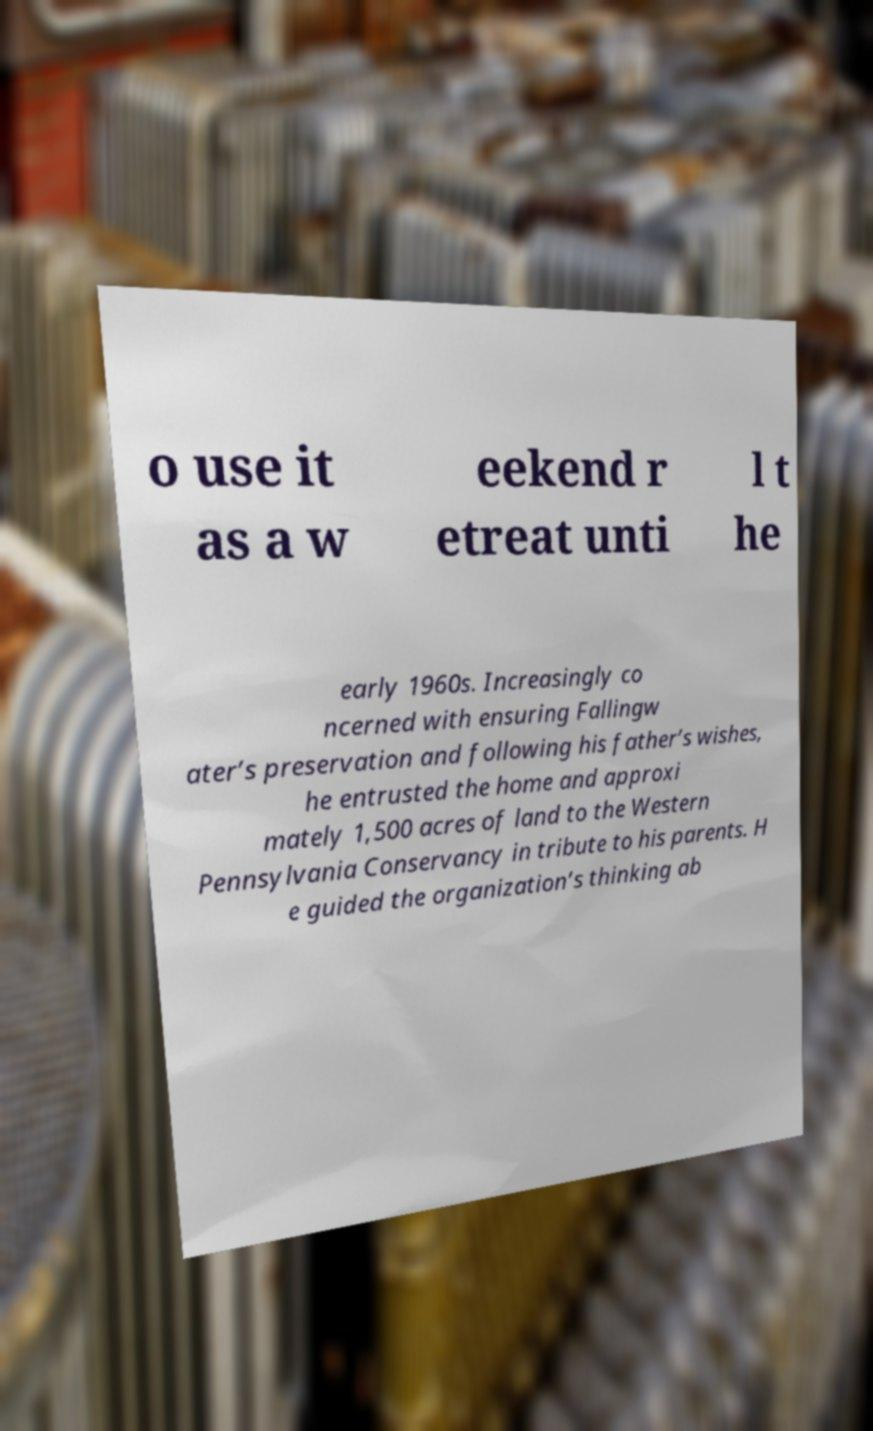Could you assist in decoding the text presented in this image and type it out clearly? o use it as a w eekend r etreat unti l t he early 1960s. Increasingly co ncerned with ensuring Fallingw ater’s preservation and following his father’s wishes, he entrusted the home and approxi mately 1,500 acres of land to the Western Pennsylvania Conservancy in tribute to his parents. H e guided the organization’s thinking ab 